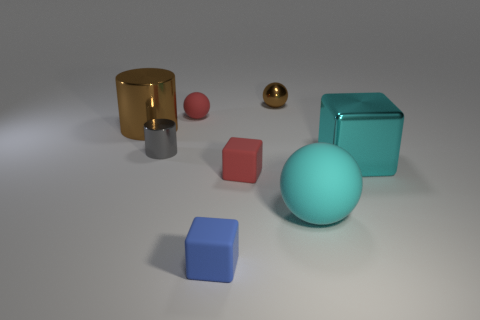What number of matte objects are big objects or tiny red objects?
Offer a very short reply. 3. Are there any blocks that have the same size as the brown ball?
Provide a succinct answer. Yes. Is the number of matte balls left of the big ball greater than the number of tiny green metal cylinders?
Your answer should be compact. Yes. What number of small objects are either metal spheres or blue rubber things?
Your answer should be compact. 2. How many cyan rubber things are the same shape as the tiny blue thing?
Your answer should be very brief. 0. There is a big thing that is behind the tiny metal object on the left side of the small brown ball; what is it made of?
Provide a short and direct response. Metal. There is a matte block in front of the small red block; what size is it?
Offer a terse response. Small. How many gray things are shiny things or shiny spheres?
Your response must be concise. 1. There is a red thing that is the same shape as the big cyan metallic thing; what is its material?
Ensure brevity in your answer.  Rubber. Are there an equal number of tiny red objects that are in front of the red rubber sphere and small red objects?
Offer a very short reply. No. 